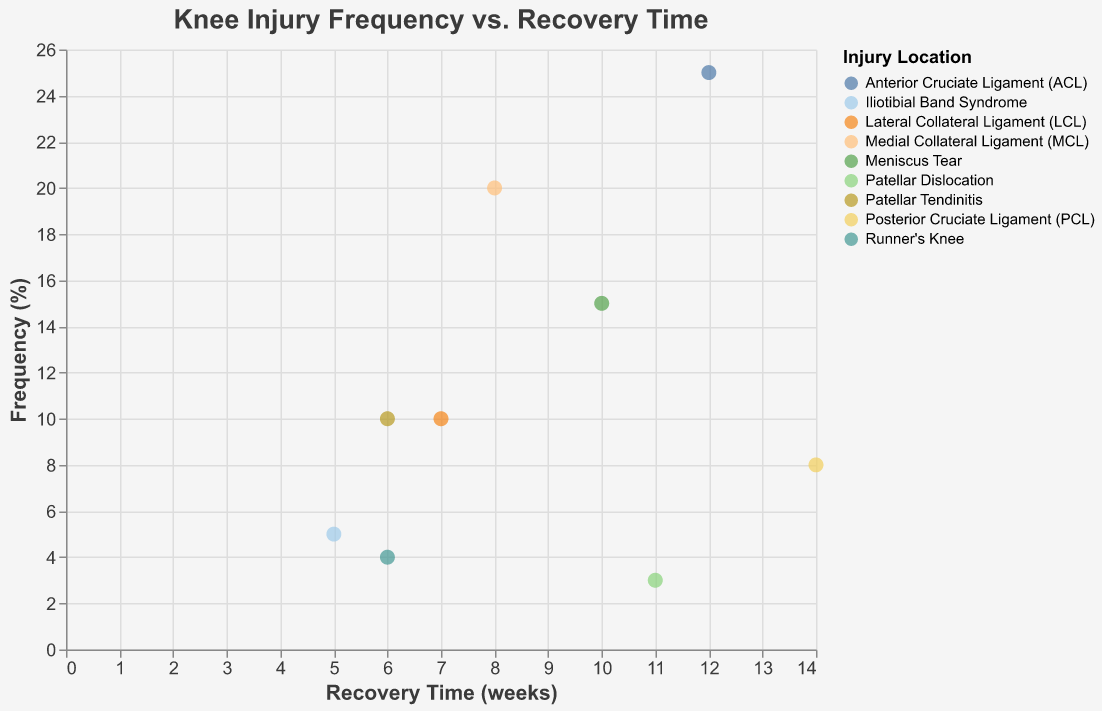What is the title of the scatter plot? The title of the scatter plot is prominently displayed at the top of the figure, above the data points.
Answer: Knee Injury Frequency vs. Recovery Time How many data points are shown in the figure? Each injury location represents a data point in the figure. By counting the unique injury types in the provided data, we can see there are 9 different injury locations.
Answer: 9 Which knee injury has the longest recovery time and what is the duration? By looking at the x-axis representing recovery time, we can identify the furthest right data point, which represents Posterior Cruciate Ligament (PCL) injury with a recovery time of 14 weeks.
Answer: Posterior Cruciate Ligament (PCL), 14 weeks What injury has the highest frequency and what is that frequency? By noting the highest point on the y-axis, which represents frequency, we can identify that Anterior Cruciate Ligament (ACL) has the highest frequency of 25%.
Answer: Anterior Cruciate Ligament (ACL), 25% Which injury locations have the same recovery time of 6 weeks, and what are their frequencies? By finding the 6-week mark on the x-axis and identifying the corresponding data points, we see Patellar Tendinitis and Runner's Knee both have a recovery time of 6 weeks. Their frequencies are 10% and 4%, respectively.
Answer: Patellar Tendinitis (10%), Runner's Knee (4%) How many injuries have a recovery time of more than 10 weeks? We can identify the data points that lie to the right of the 10-week mark on the x-axis. Three injuries have more than 10 weeks recovery: Anterior Cruciate Ligament (12 weeks), Posterior Cruciate Ligament (14 weeks), and Patellar Dislocation (11 weeks).
Answer: 3 injuries What is the average recovery time for the injuries listed? Calculate the average of all recovery times provided: (12 + 8 + 10 + 6 + 7 + 14 + 5 + 6 + 11) / 9 = 79 / 9 ≈ 8.78 weeks
Answer: 8.78 weeks Which injury has a lower recovery time, Iliotibial Band Syndrome or Lateral Collateral Ligament (LCL)? By comparing the recovery times on the x-axis, we see Iliotibial Band Syndrome recovers in 5 weeks while LCL recovers in 7 weeks, so Iliotibial Band Syndrome has a shorter recovery time.
Answer: Iliotibial Band Syndrome What is the total frequency of injuries with a recovery time of 8 weeks or less? Sum the frequencies of injuries with recovery times of 8 weeks or less: Medial Collateral Ligament (20%, 8 weeks), Patellar Tendinitis (10%, 6 weeks), Iliotibial Band Syndrome (5%, 5 weeks), and Runner's Knee (4%, 6 weeks). Total frequency = 20 + 10 + 5 + 4 = 39%.
Answer: 39% Which injury has the highest frequency with a recovery time that is less than the median recovery time of all injuries? First, calculate the median recovery time from the sorted list of recovery times (5, 6, 6, 7, 8, 10, 11, 12, 14). The median recovery time is 8 weeks. The highest frequency given a recovery time less than 8 weeks is Medial Collateral Ligament (MCL) at 8 weeks with a frequency of 20%.
Answer: Medial Collateral Ligament (MCL), 20% 